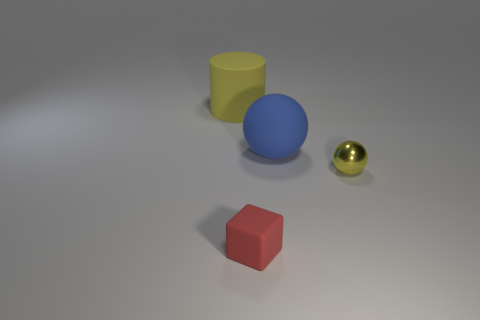Is there any other thing that is made of the same material as the small yellow thing?
Your response must be concise. No. Is the tiny rubber thing the same shape as the yellow matte thing?
Provide a succinct answer. No. What number of small objects are either blue balls or green matte balls?
Offer a very short reply. 0. There is a red block; are there any tiny yellow shiny things in front of it?
Ensure brevity in your answer.  No. Are there an equal number of cylinders behind the tiny sphere and tiny rubber things?
Keep it short and to the point. Yes. The yellow thing that is the same shape as the blue thing is what size?
Offer a terse response. Small. There is a small red rubber thing; is it the same shape as the yellow object that is to the right of the rubber cube?
Provide a short and direct response. No. There is a yellow thing that is behind the large blue sphere in front of the large yellow cylinder; what size is it?
Provide a short and direct response. Large. Are there an equal number of red matte cubes right of the yellow rubber cylinder and tiny metal things that are left of the large blue rubber object?
Ensure brevity in your answer.  No. The other thing that is the same shape as the big blue thing is what color?
Offer a terse response. Yellow. 